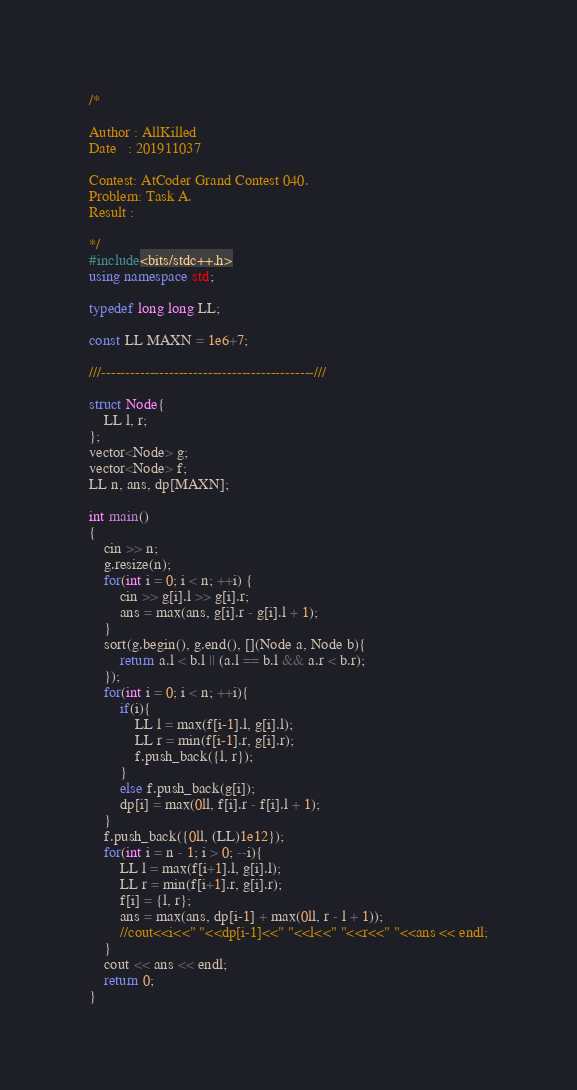Convert code to text. <code><loc_0><loc_0><loc_500><loc_500><_C++_>/*

Author : AllKilled
Date   : 201911037

Contest: AtCoder Grand Contest 040.
Problem: Task A.
Result :

*/
#include<bits/stdc++.h>
using namespace std;

typedef long long LL;

const LL MAXN = 1e6+7;

///--------------------------------------------///

struct Node{
    LL l, r;
};
vector<Node> g;
vector<Node> f;
LL n, ans, dp[MAXN];

int main()
{
    cin >> n;
    g.resize(n);
    for(int i = 0; i < n; ++i) {
        cin >> g[i].l >> g[i].r;
        ans = max(ans, g[i].r - g[i].l + 1);
    }
    sort(g.begin(), g.end(), [](Node a, Node b){
        return a.l < b.l || (a.l == b.l && a.r < b.r);
    });
    for(int i = 0; i < n; ++i){
        if(i){
            LL l = max(f[i-1].l, g[i].l);
            LL r = min(f[i-1].r, g[i].r);
            f.push_back({l, r});
        }
        else f.push_back(g[i]);
        dp[i] = max(0ll, f[i].r - f[i].l + 1);
    }
    f.push_back({0ll, (LL)1e12});
    for(int i = n - 1; i > 0; --i){
        LL l = max(f[i+1].l, g[i].l);
        LL r = min(f[i+1].r, g[i].r);
        f[i] = {l, r};
        ans = max(ans, dp[i-1] + max(0ll, r - l + 1));
        //cout<<i<<" "<<dp[i-1]<<" "<<l<<" "<<r<<" "<<ans << endl;
    }
    cout << ans << endl;
    return 0;
}
</code> 